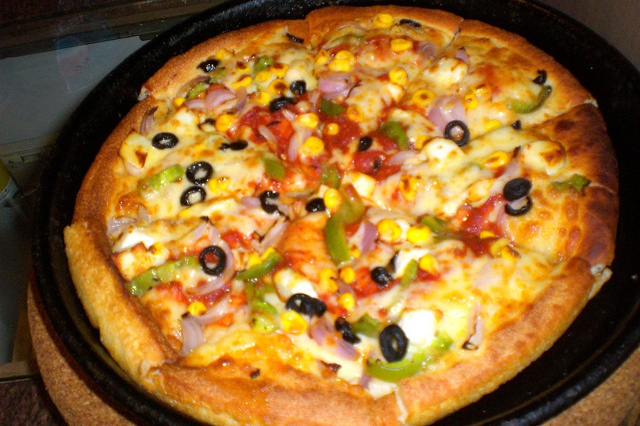Describe the objects in this image and their specific colors. I can see pizza in black, orange, and red tones and pizza in black, orange, khaki, and gold tones in this image. 